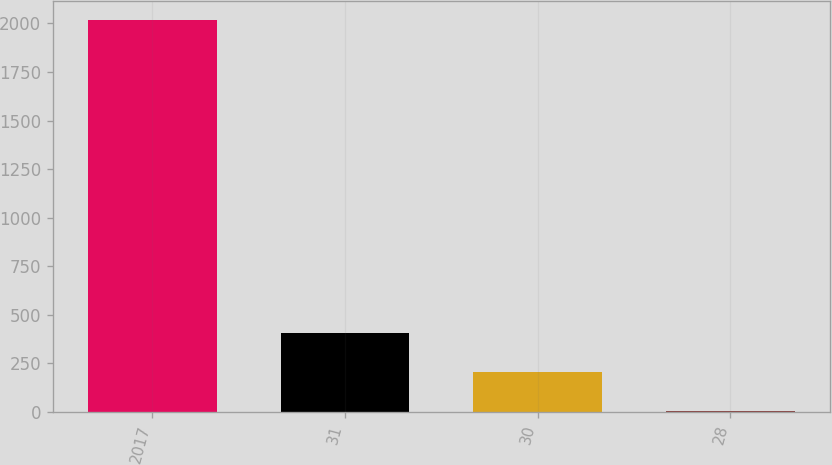Convert chart. <chart><loc_0><loc_0><loc_500><loc_500><bar_chart><fcel>2017<fcel>31<fcel>30<fcel>28<nl><fcel>2016<fcel>405.12<fcel>203.76<fcel>2.4<nl></chart> 